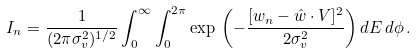<formula> <loc_0><loc_0><loc_500><loc_500>I _ { n } = \frac { 1 } { ( 2 \pi \sigma _ { v } ^ { 2 } ) ^ { 1 / 2 } } \int _ { 0 } ^ { \infty } \int _ { 0 } ^ { 2 \pi } \exp \, { \left ( - { \frac { [ w _ { n } - { { \hat { w } } \cdot { V } } ] ^ { 2 } } { 2 \sigma _ { v } ^ { 2 } } } \right ) } \, d E \, d \phi \, .</formula> 